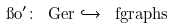<formula> <loc_0><loc_0><loc_500><loc_500>\i o ^ { \prime } \colon \ G e r \hookrightarrow \ f g r a p h s</formula> 